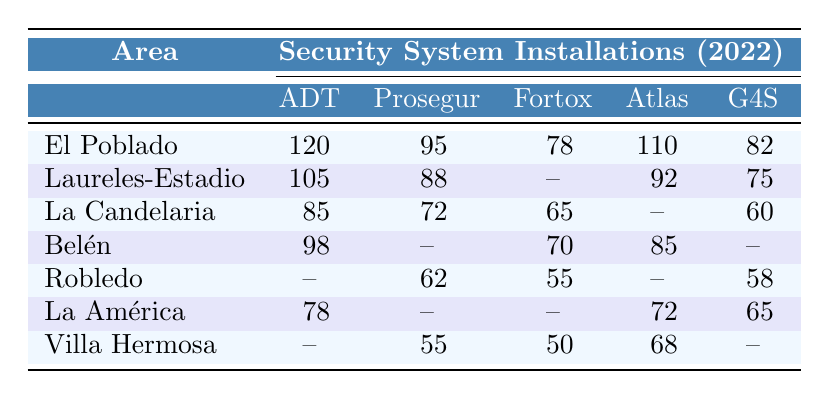What area has the highest number of ADT installations? The table shows that El Poblado has 120 ADT installations, which is higher than any other area listed.
Answer: El Poblado Which area has the least number of total installations of security systems? By examining the installations, Robledo has 62 + 55 + 58 = 175 total installations. The other areas with data show higher totals.
Answer: Robledo What is the difference in Fortox installations between La Candelaria and Belén? La Candelaria has 65 Fortox installations, while Belén has 70. Calculating the difference: 70 - 65 = 5.
Answer: 5 Do any areas have no installations of G4S security systems? By looking at the table, Robledo and Villa Hermosa both show zero installations for G4S.
Answer: Yes Which area has the second highest number of Prosegur installations? The second highest number of Prosegur installations is found in Laureles-Estadio with 88, while El Poblado has the highest at 95.
Answer: Laureles-Estadio What is the total number of installations for La América? For La América, we sum the installations: 78 (ADT) + 0 (Prosegur) + 0 (Fortox) + 72 (Atlas) + 65 (G4S) = 215.
Answer: 215 Is it true that El Poblado has more Atlas Seguridad installations than Laureles-Estadio? El Poblado has 110 Atlas installations and Laureles-Estadio has 92 installations, so it is true that El Poblado has more.
Answer: Yes Are there any areas that have installations for all five security systems? By reviewing the table, it’s clear that no area has installations for all five systems because several show zero installations for different systems.
Answer: No What is the average number of installations for security systems in Villa Hermosa? Villa Hermosa has installations of 55 (Prosegur) + 50 (Fortox) + 68 (Atlas) = 173, divided by 4 (only those with data): 173 / 3 = 57.67.
Answer: 57.67 Which security system has the highest total number of installations across all areas? Summing the installations for each security system across all areas: ADT (120+105+85+98+0+78+0 = 486), Prosegur (95+88+72+0+62+0+55 = 372), and so forth shows that ADT has the highest total.
Answer: ADT 